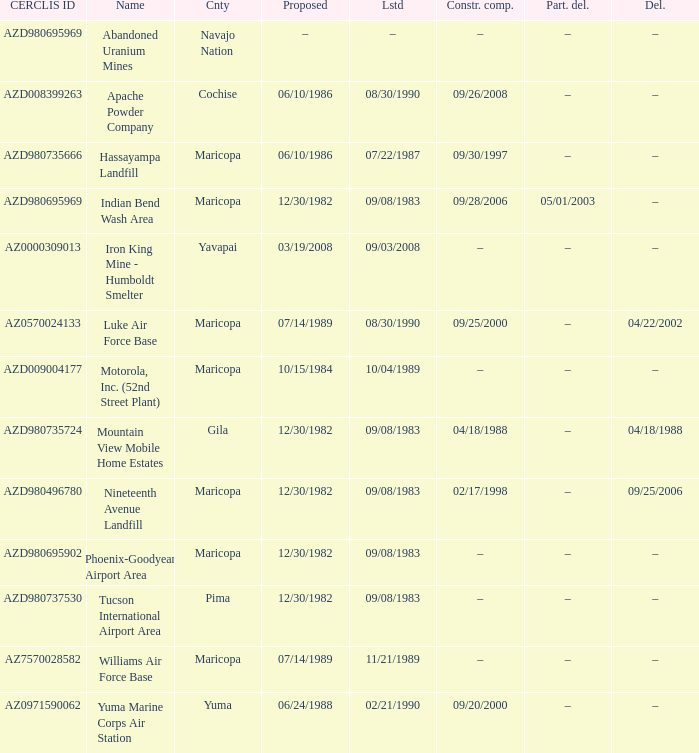When was the site partially deleted when the cerclis id is az7570028582? –. 